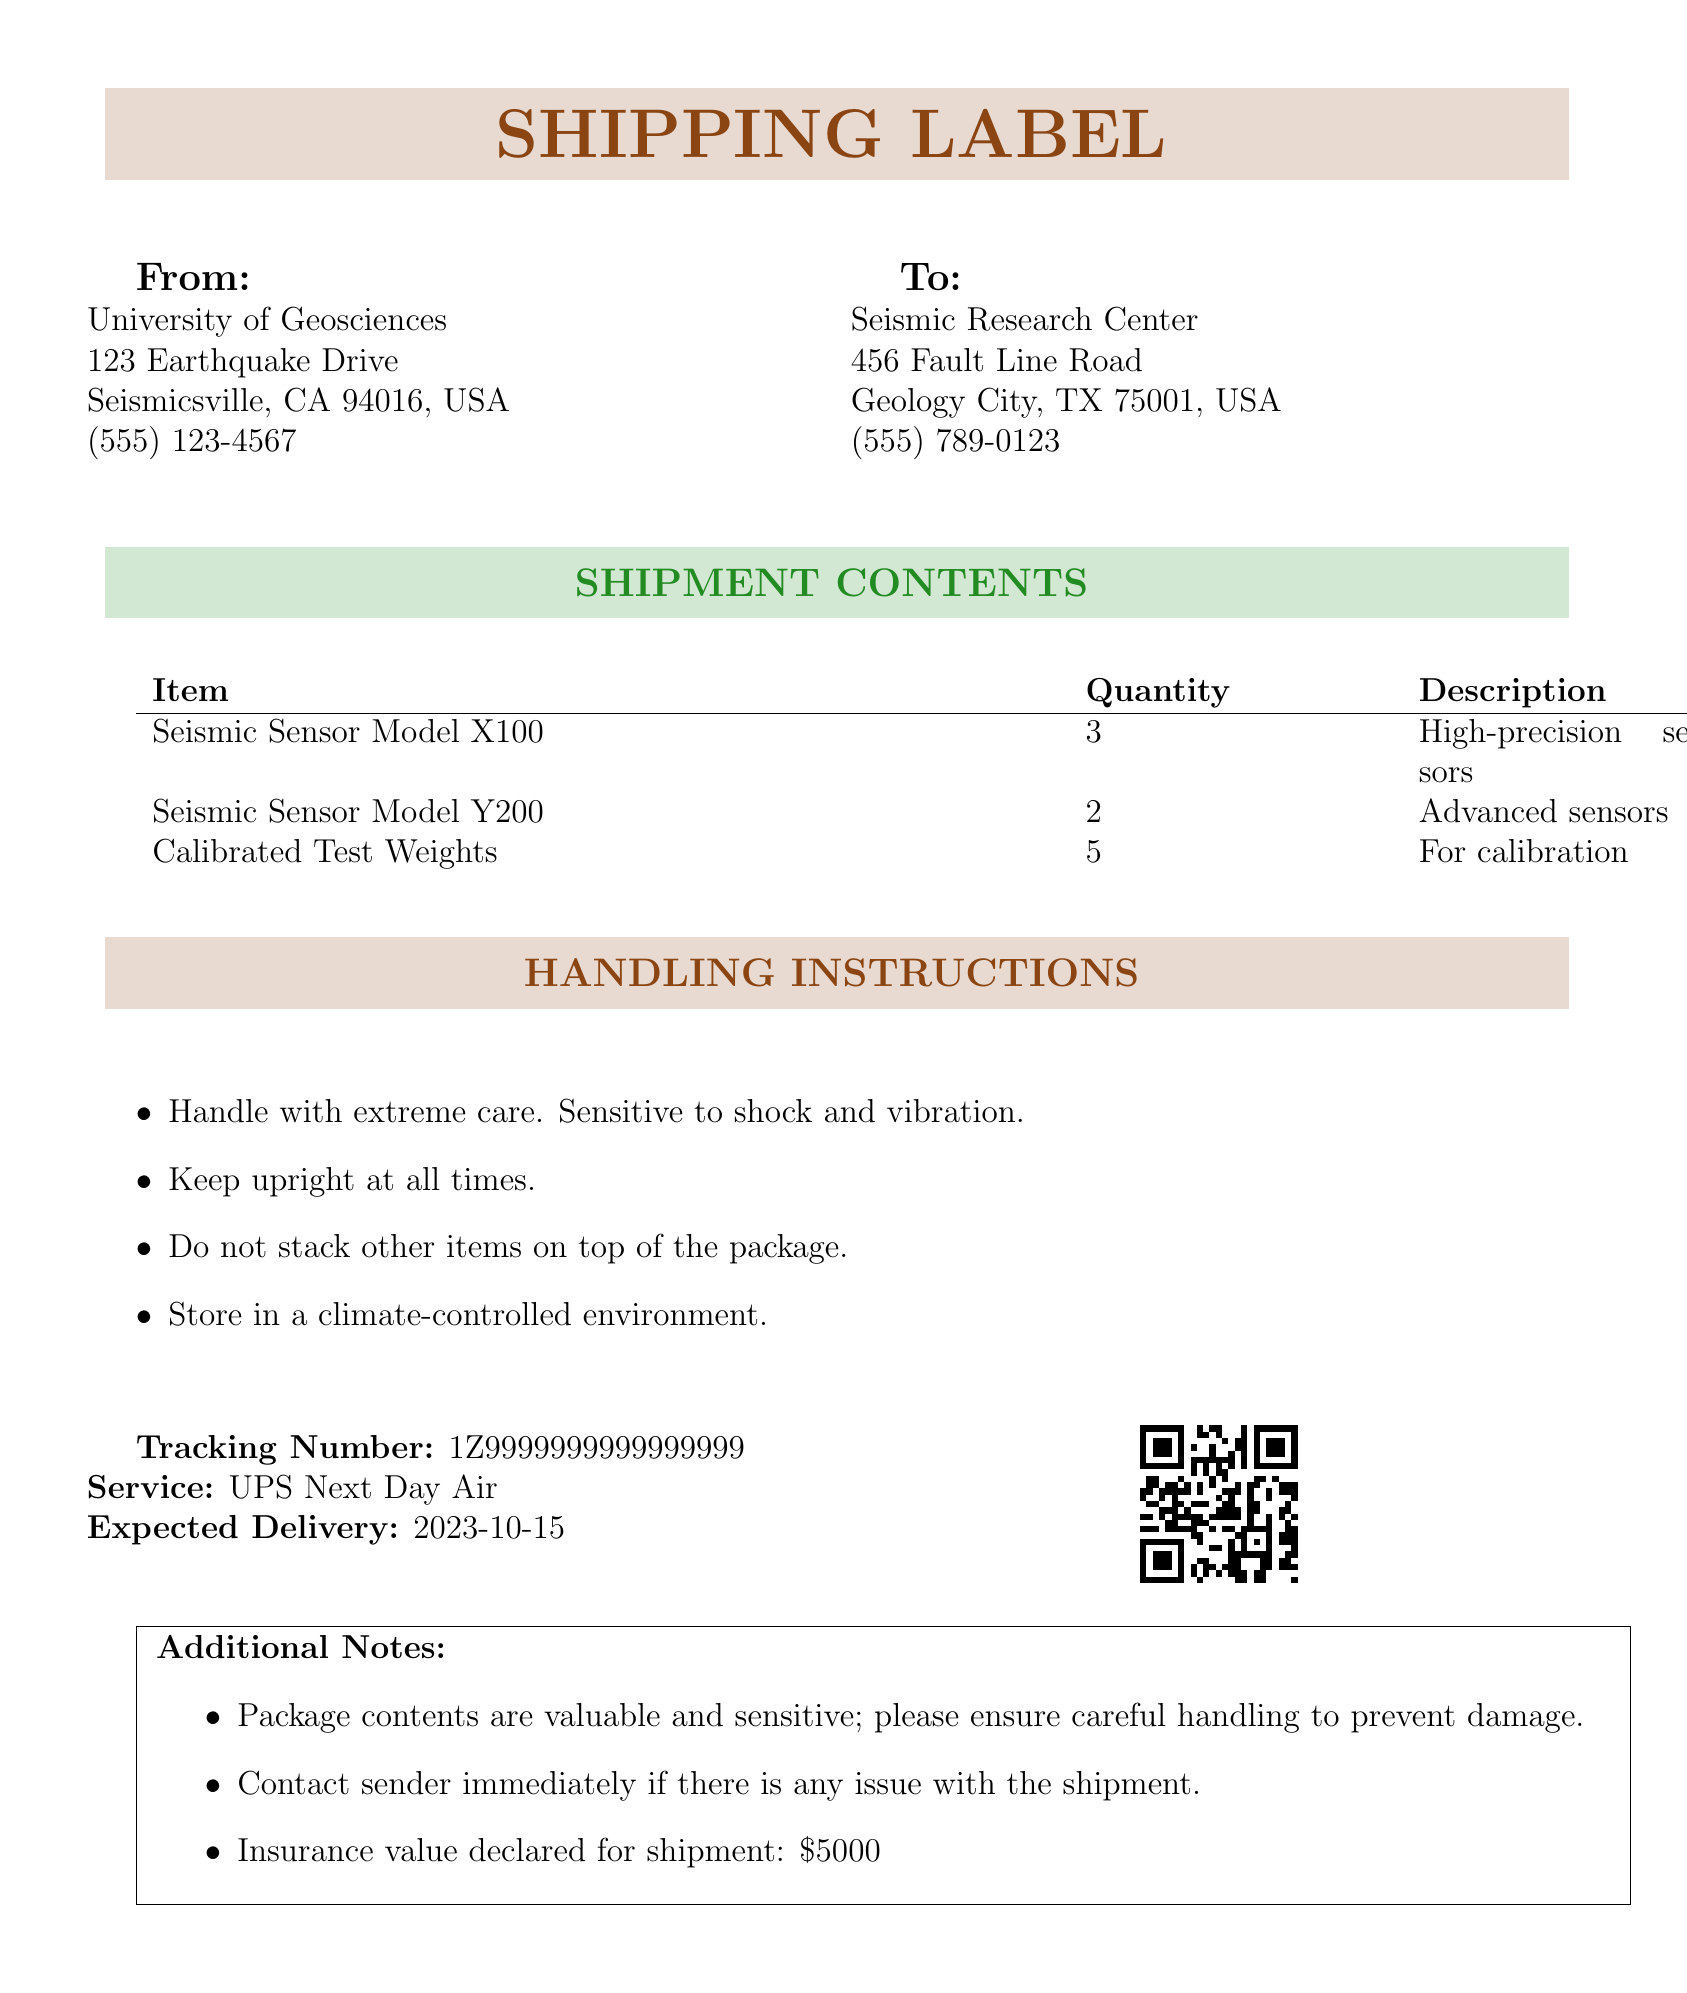What is the tracking number? The tracking number is a unique identifier for the shipment, which can be found in the document.
Answer: 1Z9999999999999999 What is the service used for shipping? The service used for shipping is indicated in the document under the tracking information.
Answer: UPS Next Day Air How many Seismic Sensor Model X100 are being shipped? The quantity of Seismic Sensor Model X100 in the shipment can be found in the contents table.
Answer: 3 What are the handling instructions regarding stacking? The document states specific handling instructions that can be found under the handling instructions section.
Answer: Do not stack other items on top of the package What is the total insurance value declared for the shipment? The total insurance value can be found in the additional notes section of the document.
Answer: $5000 What is the expected delivery date? The expected delivery date is mentioned in the tracking information section of the document.
Answer: 2023-10-15 What should you do if there is an issue with the shipment? The document provides instructions on what to do in case of issues with the shipment in the additional notes section.
Answer: Contact sender immediately How many items of Calibrated Test Weights are included in the shipment? The quantity of Calibrated Test Weights can be found in the contents table of the document.
Answer: 5 